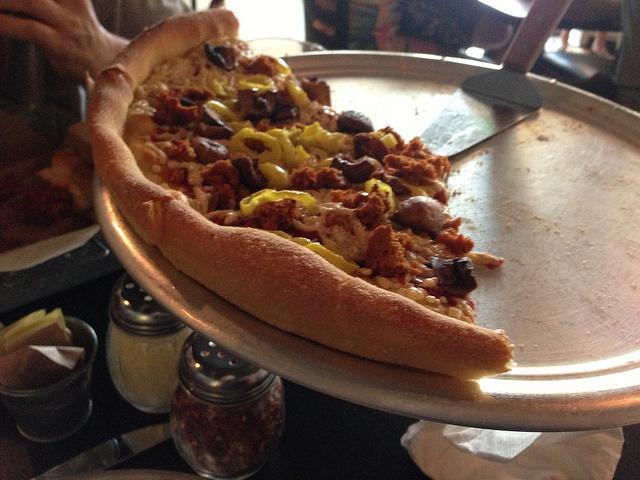How many slices are left?
Give a very brief answer. 3. How many bottles can be seen?
Give a very brief answer. 2. How many cars are in the intersection?
Give a very brief answer. 0. 